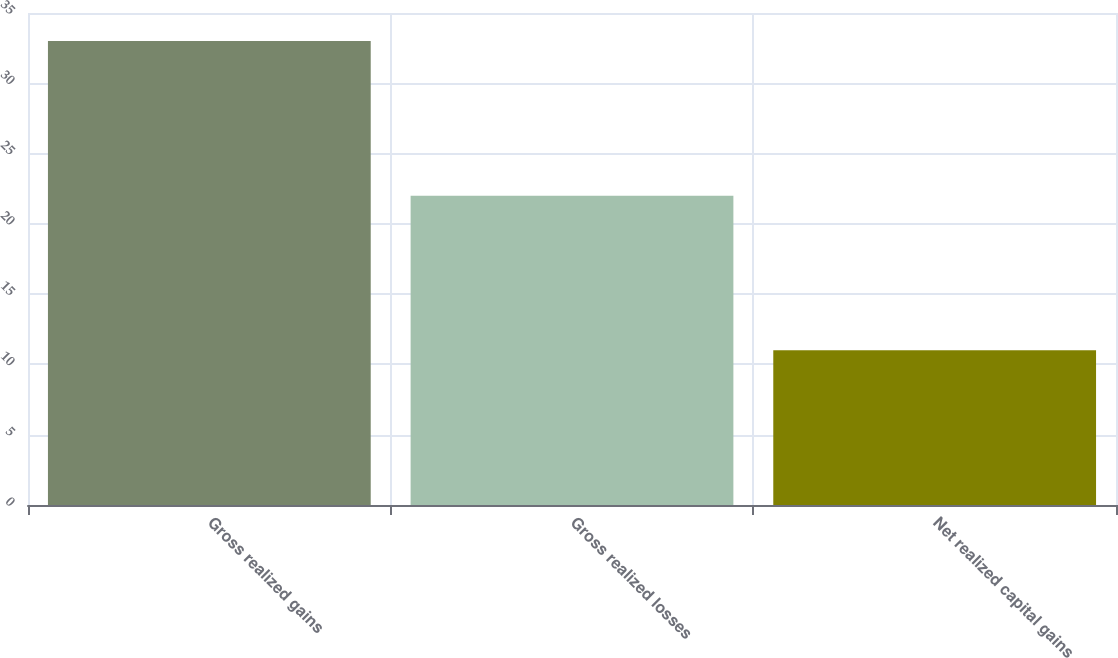<chart> <loc_0><loc_0><loc_500><loc_500><bar_chart><fcel>Gross realized gains<fcel>Gross realized losses<fcel>Net realized capital gains<nl><fcel>33<fcel>22<fcel>11<nl></chart> 